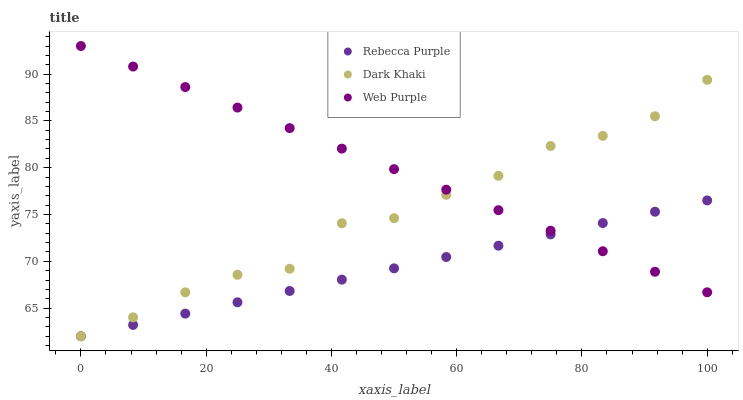Does Rebecca Purple have the minimum area under the curve?
Answer yes or no. Yes. Does Web Purple have the maximum area under the curve?
Answer yes or no. Yes. Does Web Purple have the minimum area under the curve?
Answer yes or no. No. Does Rebecca Purple have the maximum area under the curve?
Answer yes or no. No. Is Web Purple the smoothest?
Answer yes or no. Yes. Is Dark Khaki the roughest?
Answer yes or no. Yes. Is Rebecca Purple the smoothest?
Answer yes or no. No. Is Rebecca Purple the roughest?
Answer yes or no. No. Does Dark Khaki have the lowest value?
Answer yes or no. Yes. Does Web Purple have the lowest value?
Answer yes or no. No. Does Web Purple have the highest value?
Answer yes or no. Yes. Does Rebecca Purple have the highest value?
Answer yes or no. No. Does Rebecca Purple intersect Web Purple?
Answer yes or no. Yes. Is Rebecca Purple less than Web Purple?
Answer yes or no. No. Is Rebecca Purple greater than Web Purple?
Answer yes or no. No. 